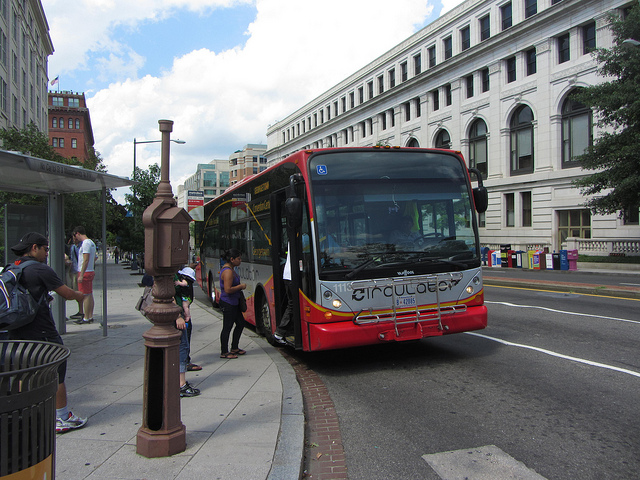Extract all visible text content from this image. 1113 ciraulotor 